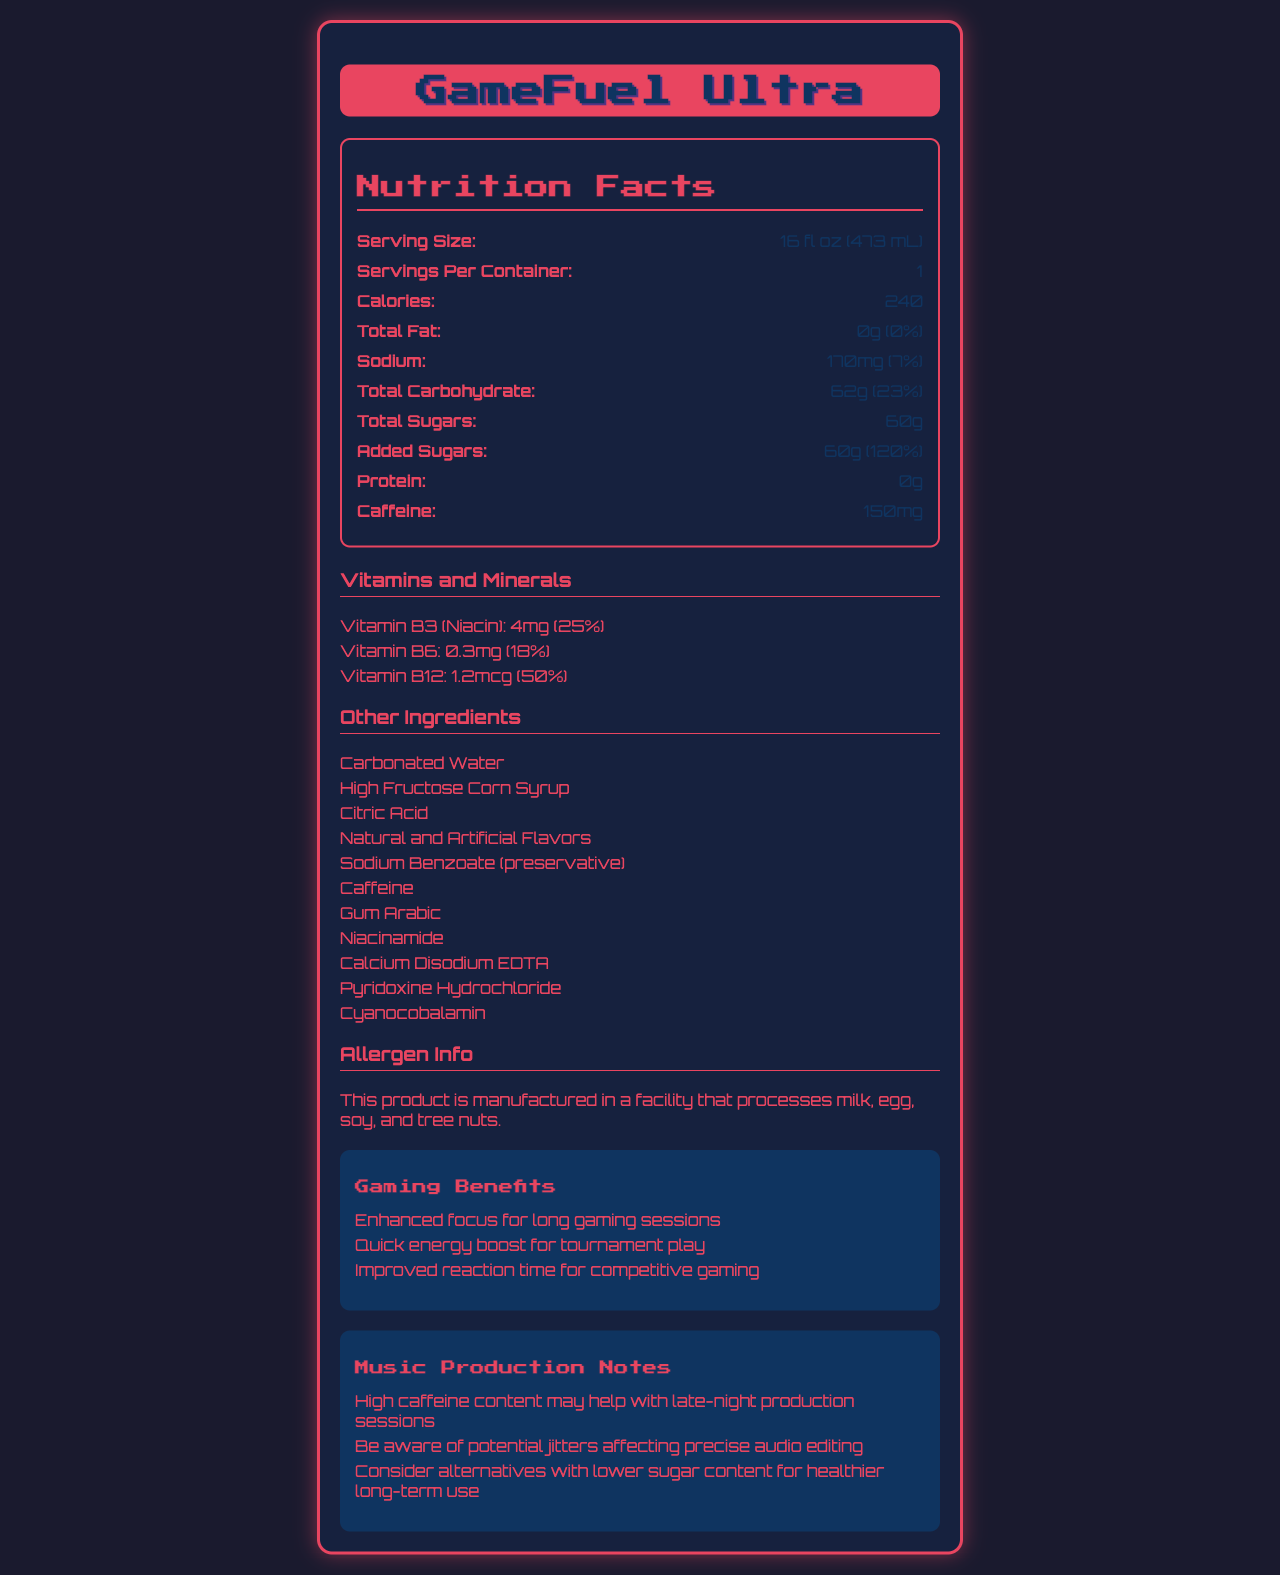what is the serving size of GameFuel Ultra? The serving size is listed directly in the nutrition facts section of the document.
Answer: 16 fl oz (473 mL) how many calories are in a serving of GameFuel Ultra? The calories per serving are listed in the nutrition facts section.
Answer: 240 what is the total carbohydrate content per serving? The total carbohydrate content is listed as 62g in the nutrition facts section.
Answer: 62g how much caffeine does GameFuel Ultra contain per serving? The caffeine amount per serving is stated as 150mg in the nutrition facts section.
Answer: 150mg how many grams of sugar are in GameFuel Ultra? The total sugars amount is listed as 60g in the nutrition facts section.
Answer: 60g what percentage of the daily value is the added sugars in GameFuel Ultra? The daily value percentage for added sugars is listed as 120% in the nutrition facts section.
Answer: 120% how much sodium is in one serving? The sodium content is stated as 170mg under the nutrition facts.
Answer: 170mg which vitamin has the highest daily value percentage in GameFuel Ultra? 
I. Vitamin B3 (Niacin) 
II. Vitamin B6 
III. Vitamin B12
IV. Vitamin C The daily value percentage for Vitamin B12 is 50%, the highest among the listed vitamins/minerals.
Answer: III. Vitamin B12 which ingredient is used as a preservative in GameFuel Ultra? 
A. Citric Acid 
B. Sodium Benzoate 
C. Caffeine 
D. Calcium Disodium EDTA Sodium Benzoate is listed in the ingredients as a preservative.
Answer: B. Sodium Benzoate does GameFuel Ultra contain any protein? The protein content is listed as 0g in the nutrition facts section.
Answer: No is GameFuel Ultra manufactured in a facility that processes nuts? The allergen information states that it is manufactured in a facility that processes milk, egg, soy, and tree nuts.
Answer: Yes how might high caffeine content in GameFuel Ultra benefit music production sessions? The document mentions high caffeine content may help with late-night production sessions under music production notes.
Answer: Helps with late-night production summarize the main nutritional facts and benefits of GameFuel Ultra. This summary captures the essential nutritional facts, the ingredients, and benefits for both gamers and music producers as noted in the document.
Answer: GameFuel Ultra contains 240 calories per 16 fl oz serving with 0g fat, 170mg sodium, 62g carbohydrates (60g sugars, 60g added sugars), 0g protein, and 150mg caffeine. It includes vitamins B3, B6, and B12 and offers benefits like enhanced focus, quick energy boost, and improved reaction time for gamers, along with high caffeine content that can aid late-night music production. what type of sweetener is used in GameFuel Ultra? The document lists high fructose corn syrup but does not provide a categorical type.
Answer: Not enough information 